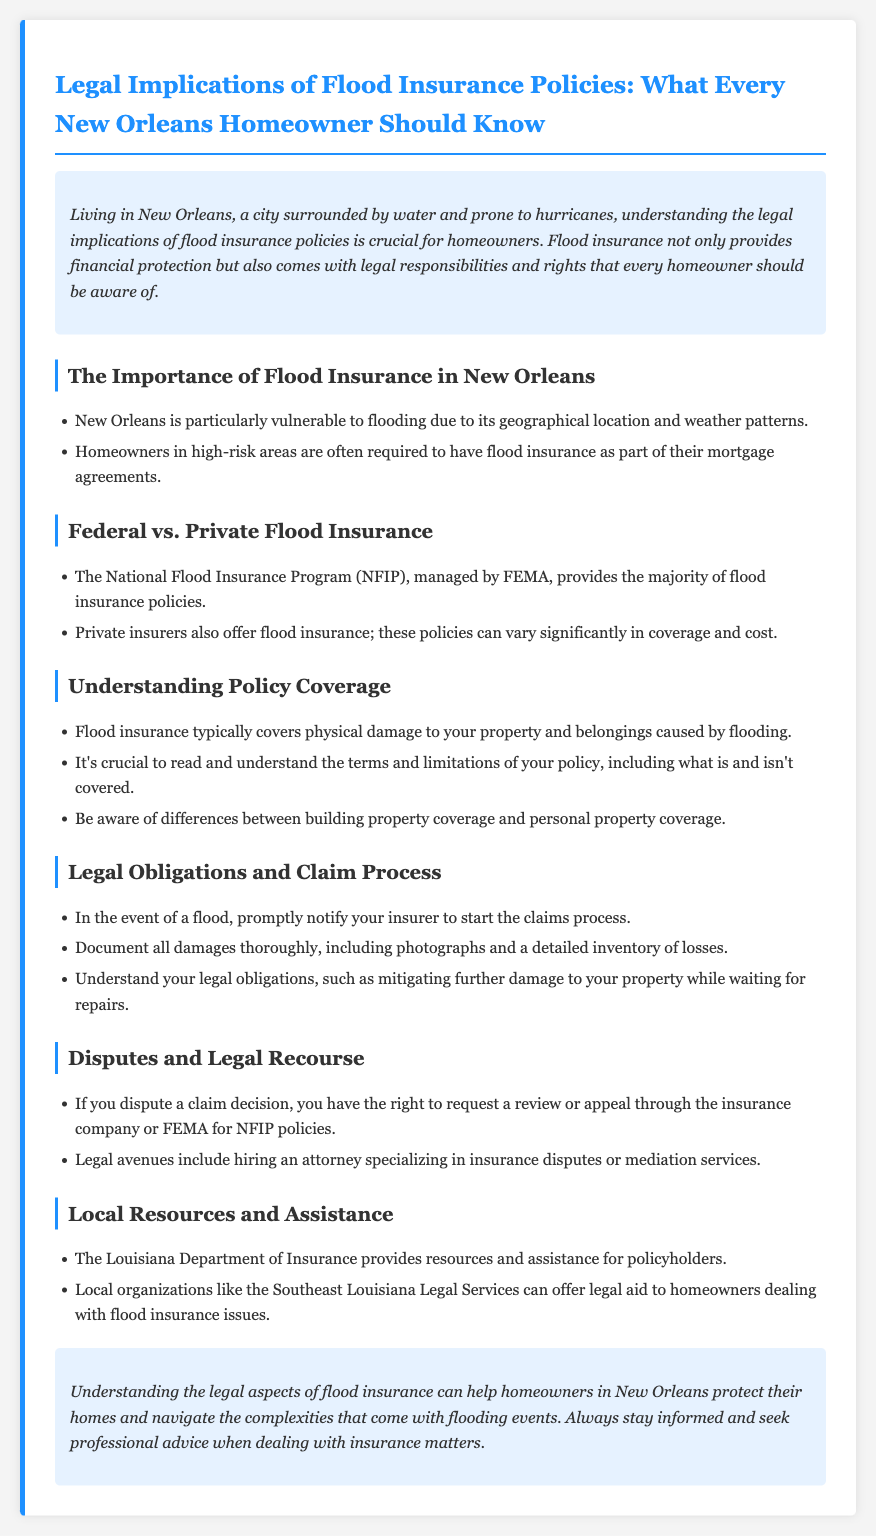what is the title of the document? The title of the document is specified at the beginning, outlining the main focus of the content.
Answer: Legal Implications of Flood Insurance Policies: What Every New Orleans Homeowner Should Know what program manages the majority of flood insurance policies? The document mentions that the National Flood Insurance Program is managed by FEMA.
Answer: National Flood Insurance Program what should homeowners document after a flood? The document advises homeowners to document all damages thoroughly, including specific details.
Answer: Damages what legal obligation must homeowners be aware of during the claims process? The document states that homeowners have a duty to mitigate further damage while awaiting repairs.
Answer: Mitigating further damage who provides resources and assistance for policyholders in Louisiana? The document refers to the Louisiana Department of Insurance as a resource for policyholders.
Answer: Louisiana Department of Insurance what type of insurance do homeowners in high-risk areas often require? The document notes that homeowners in these areas are typically required to have flood insurance.
Answer: Flood insurance which local organization can offer legal aid regarding flood insurance issues? The document lists Southeast Louisiana Legal Services as a resource for legal assistance.
Answer: Southeast Louisiana Legal Services what is recommended if a claim decision is disputed? The document outlines the right to request a review or appeal in the case of a disputed claim.
Answer: Request a review or appeal 